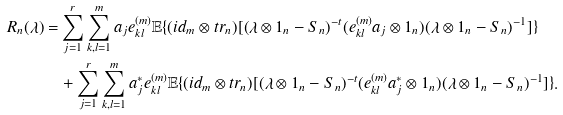Convert formula to latex. <formula><loc_0><loc_0><loc_500><loc_500>R _ { n } ( \lambda ) = & \sum _ { j = 1 } ^ { r } \sum _ { k , l = 1 } ^ { m } a _ { j } e _ { k l } ^ { ( m ) } \mathbb { E } \{ ( i d _ { m } \otimes t r _ { n } ) [ ( \lambda \otimes 1 _ { n } - S _ { n } ) ^ { - t } ( e _ { k l } ^ { ( m ) } a _ { j } \otimes 1 _ { n } ) ( \lambda \otimes 1 _ { n } - S _ { n } ) ^ { - 1 } ] \} \\ & + \sum _ { j = 1 } ^ { r } \sum _ { k , l = 1 } ^ { m } a _ { j } ^ { * } e _ { k l } ^ { ( m ) } \mathbb { E } \{ ( i d _ { m } \otimes t r _ { n } ) [ ( \lambda \otimes 1 _ { n } - S _ { n } ) ^ { - t } ( e _ { k l } ^ { ( m ) } a _ { j } ^ { * } \otimes 1 _ { n } ) ( \lambda \otimes 1 _ { n } - S _ { n } ) ^ { - 1 } ] \} .</formula> 